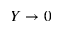Convert formula to latex. <formula><loc_0><loc_0><loc_500><loc_500>Y \to 0</formula> 